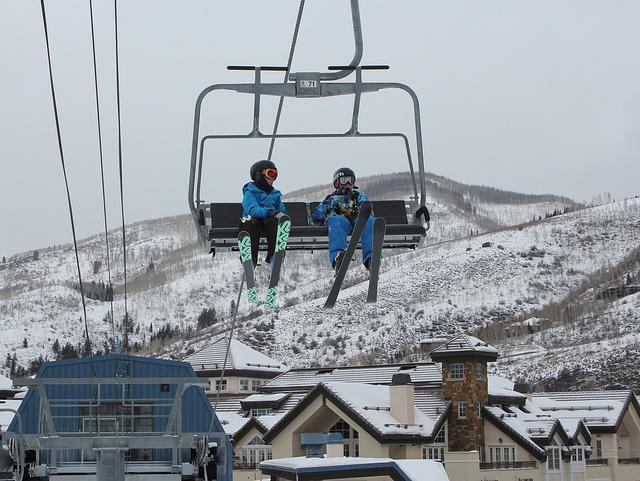Which comparative elevation do the seated people wish for?
Indicate the correct response by choosing from the four available options to answer the question.
Options: Lower, none, same, higher. Higher. 